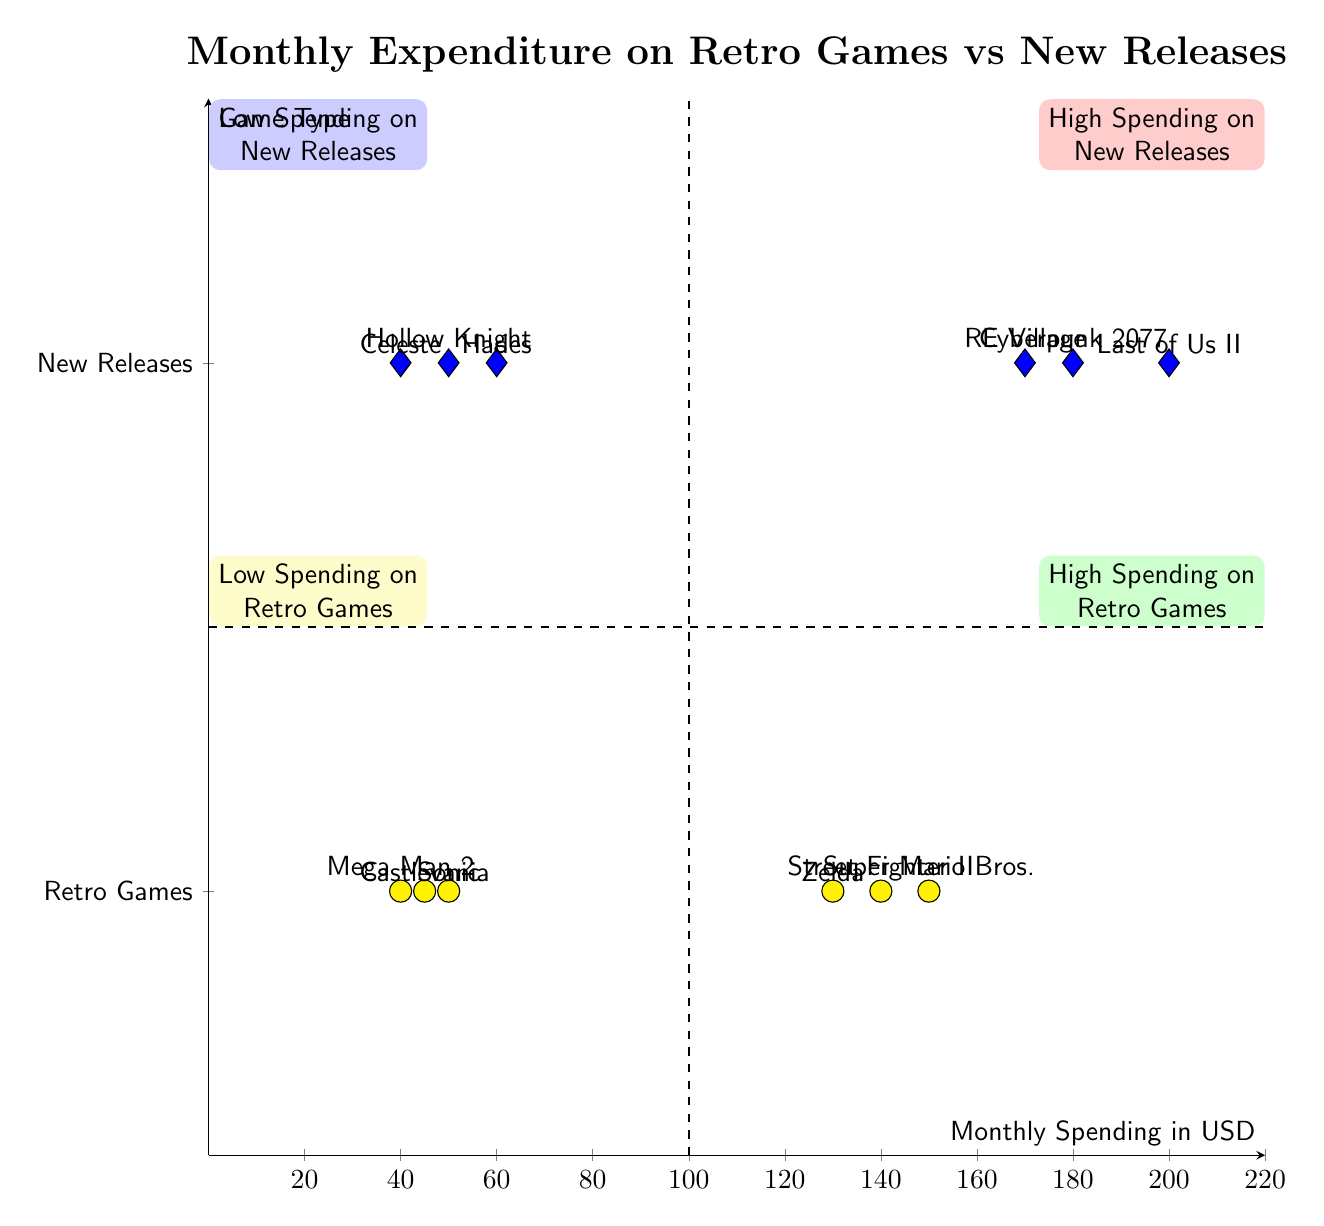What are the highest spending retro games? The highest spending retro games are found in the quadrant labeled "High Spending on Retro Games." They are Super Mario Bros., The Legend of Zelda, and Street Fighter II with spending amounts of 150, 130, and 140 respectively.
Answer: Super Mario Bros., The Legend of Zelda, Street Fighter II Which new release has the highest spending? To find the highest spending in the "High Spending on New Releases" quadrant, we look for the game with the highest dollar amount. The Last of Us Part II is the highest at 200.
Answer: The Last of Us Part II How many games are in the low spending on new releases quadrant? The "Low Spending on New Releases" quadrant contains three games: Hades, Celeste, and Hollow Knight.
Answer: Three Which game had the lowest spending overall? In the quadrants for both retro games and new releases, we check the lowest values. Mega Man 2 has the lowest spending at 40, which is the minimum value in the diagram.
Answer: Mega Man 2 What is the total spending on high spending new releases? To compute the total spending in the "High Spending on New Releases," we sum the spending amounts: 200 (The Last of Us Part II) + 180 (Cyberpunk 2077) + 170 (Resident Evil Village) = 550.
Answer: 550 How many games are classified as high spending on retro games? The "High Spending on Retro Games" quadrant lists three games: Super Mario Bros., The Legend of Zelda, and Street Fighter II.
Answer: Three What is the spending of Castlevania? Castlevania is located in the "Low Spending on Retro Games" quadrant with a spending amount of 45.
Answer: 45 Which quadrant contains Sonic the Hedgehog? Sonic the Hedgehog is found in the "Low Spending on Retro Games" quadrant. This is determined by checking where its spending of 50 falls in the diagram.
Answer: Low Spending on Retro Games 